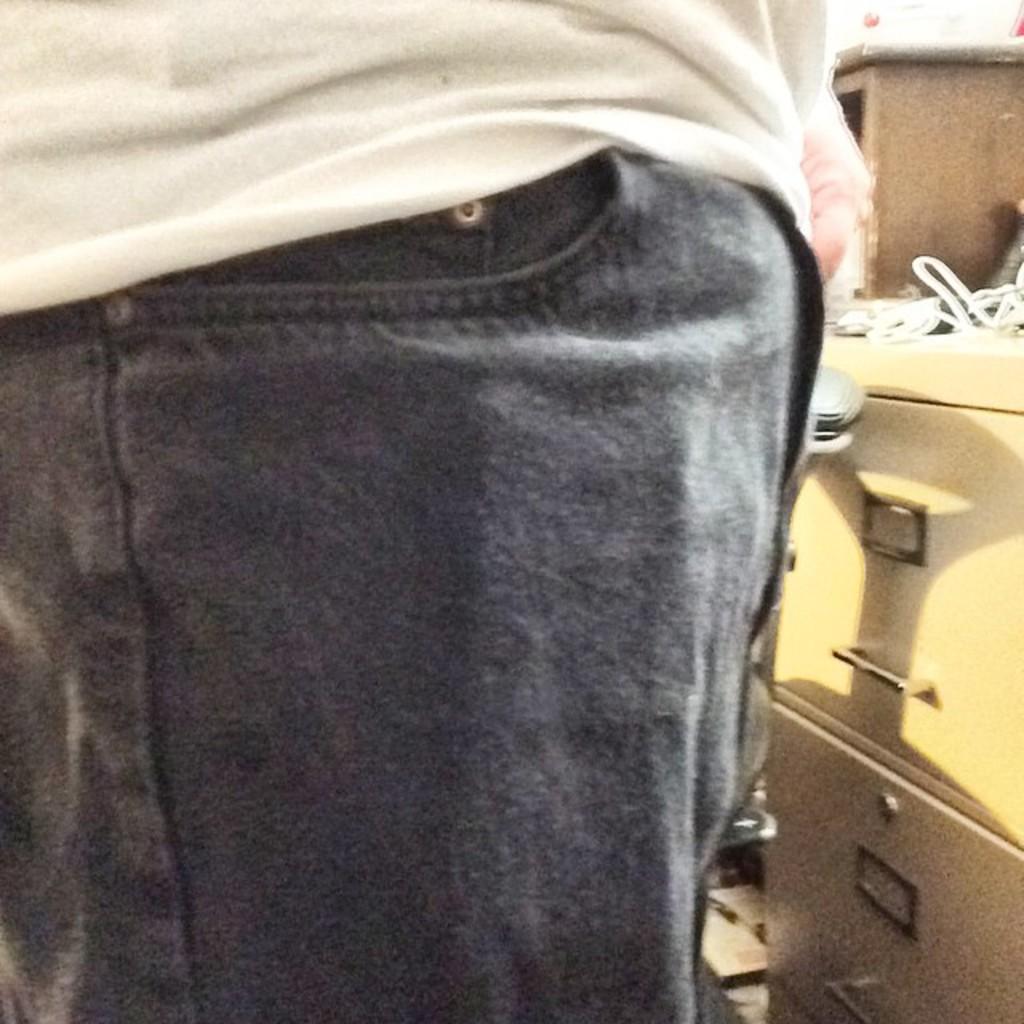Can you describe this image briefly? In this picture we can see the pant pocket and a white shirt of a person standing near a table with drawers. 